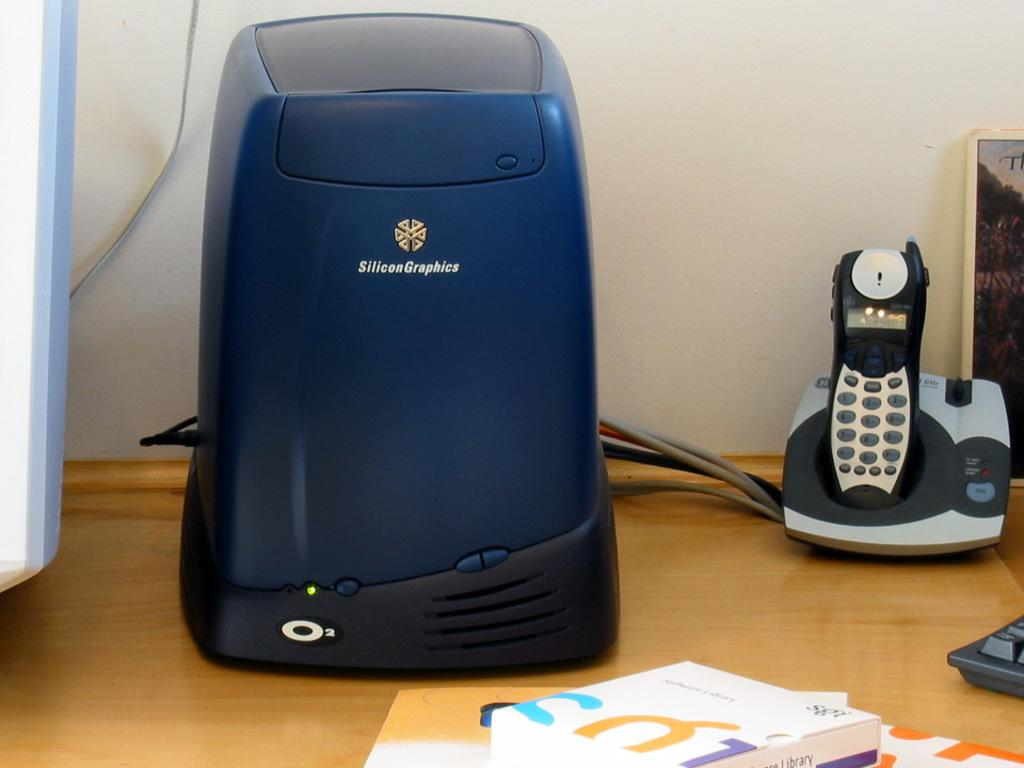<image>
Offer a succinct explanation of the picture presented. Blue computer terminal made by the company SiliconeGraphics sitting on a desk. 